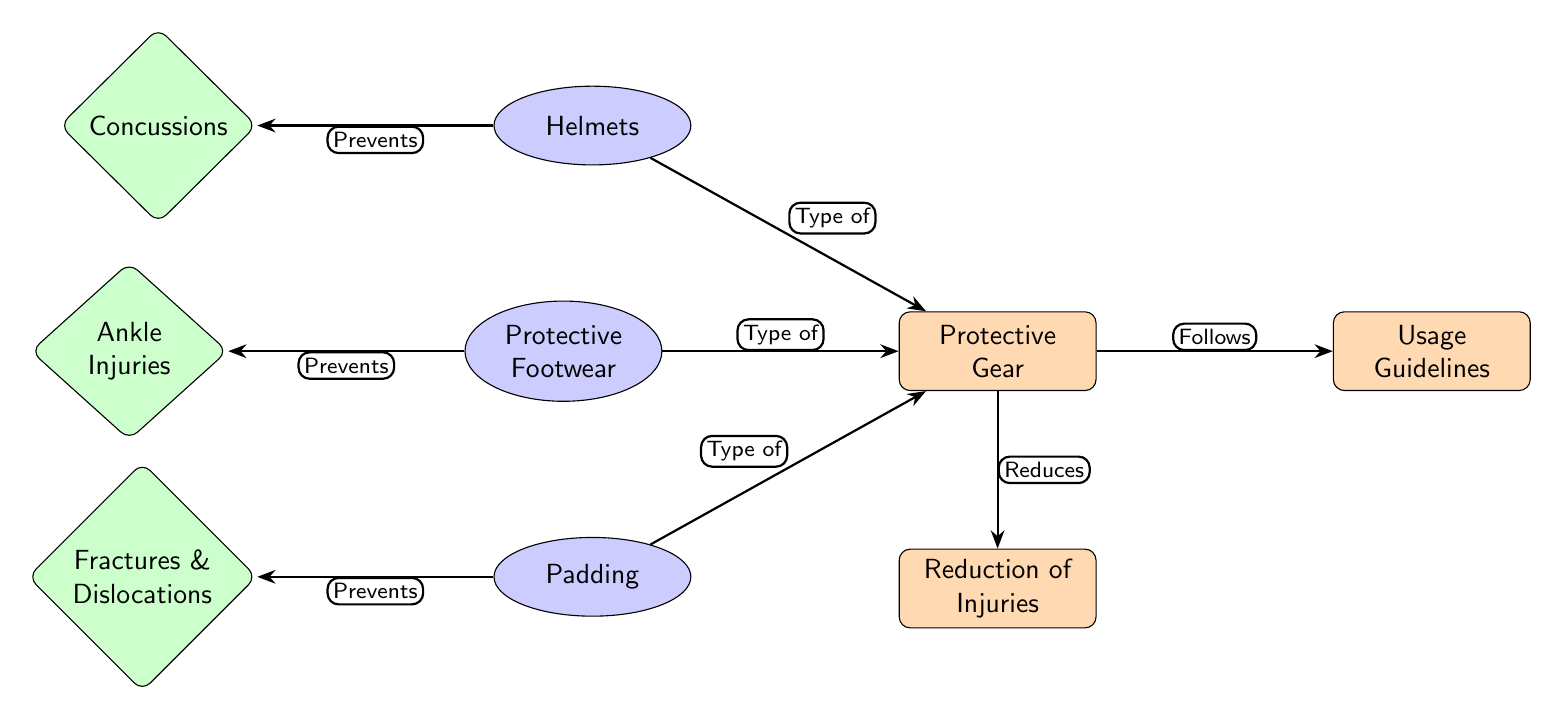What is the main subject of the diagram? The main subject of the diagram is "Protective Gear," as indicated at the top of the diagram in the main node.
Answer: Protective Gear How many types of protective gear are mentioned in the diagram? The diagram mentions three types of protective gear: helmets, protective footwear, and padding. This is evident from the three secondary nodes branching from the main node.
Answer: Three Which injuries do helmets help prevent? The diagram specifies that helmets prevent concussions, shown by the edge connecting helmets to the concussions node.
Answer: Concussions What do usage guidelines relate to in the context of this diagram? The usage guidelines in the diagram relate to protective gear, as indicated by the edge labeled "Follows" linking the usage guidelines node to the protective gear node.
Answer: Protective Gear How many injuries are listed that protective gear helps prevent? The diagram lists three injuries: concussions, ankle injuries, and fractures & dislocations, visible from the tertiary nodes connected to their respective secondary nodes.
Answer: Three What is the relationship between protective footwear and ankle injuries? The relationship is that protective footwear "Prevents" ankle injuries, as shown by the directed edge connecting the footwear node to the ankle injuries node.
Answer: Prevents What type of edge connects protective gear to reduction of injuries? The type of edge connecting protective gear to reduction of injuries is labeled "Reduces," indicating the function of protective gear in minimizing injuries.
Answer: Reduces How does padding relate to the injuries mentioned in the diagram? Padding is a type of protective gear that specifically "Prevents" fractures and dislocations, as indicated by the edge connecting padding to the fractures & dislocations node.
Answer: Prevents fractures & dislocations Which nodes are connected to the usage guidelines node? The usage guidelines node is connected to a single node, which is the protective gear node, as depicted by the "Follows" edge in the diagram.
Answer: Protective Gear 